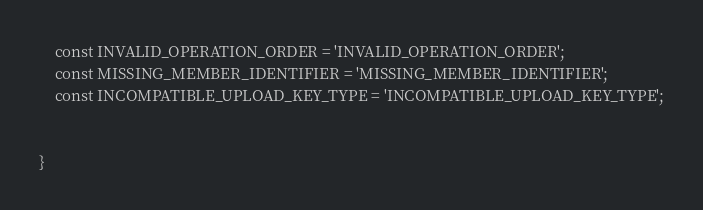<code> <loc_0><loc_0><loc_500><loc_500><_PHP_>    const INVALID_OPERATION_ORDER = 'INVALID_OPERATION_ORDER';
    const MISSING_MEMBER_IDENTIFIER = 'MISSING_MEMBER_IDENTIFIER';
    const INCOMPATIBLE_UPLOAD_KEY_TYPE = 'INCOMPATIBLE_UPLOAD_KEY_TYPE';


}
</code> 